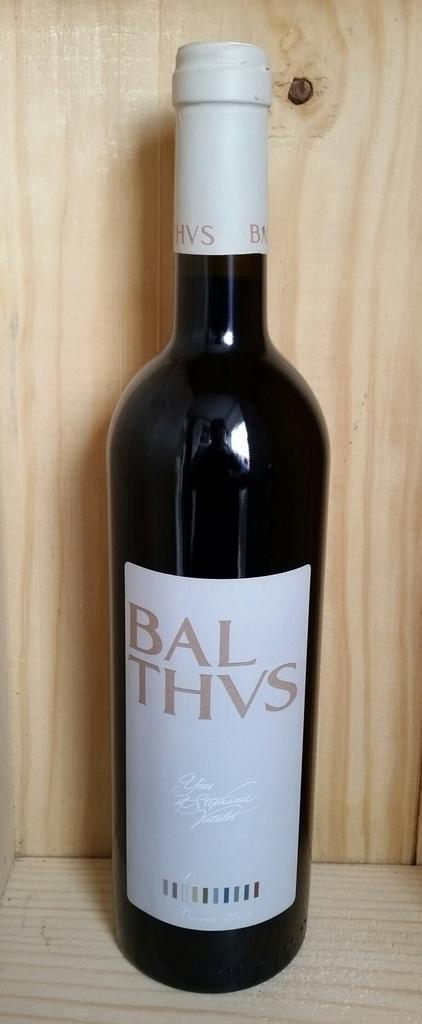<image>
Describe the image concisely. the word Balthvs that is on a bottle 